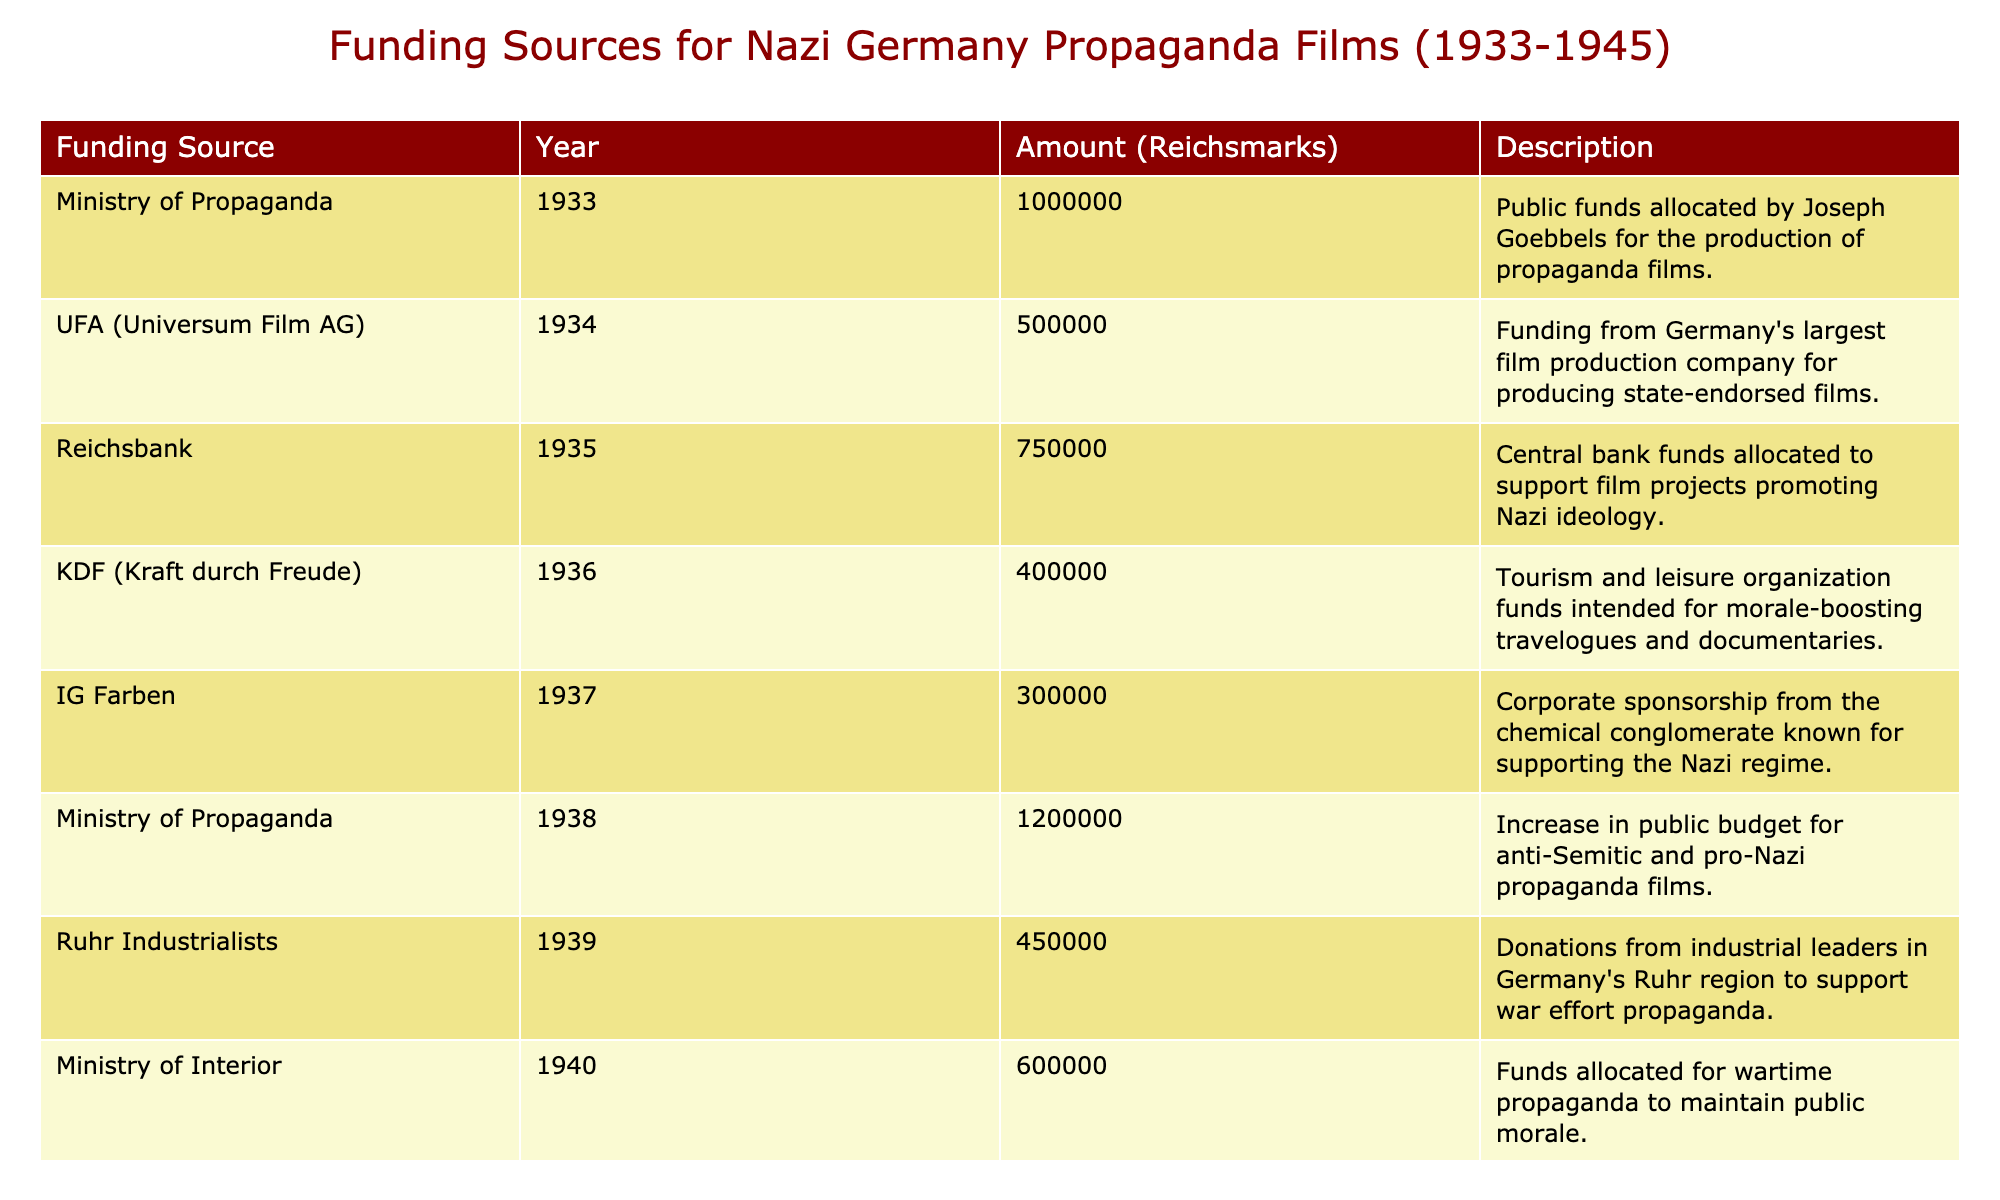What was the total funding from the Ministry of Propaganda across all years? The Ministry of Propaganda provided funding in the years 1933 (1,000,000), 1938 (1,200,000), 1941 (1,300,000), and 1945 (1,400,000). Summing these amounts gives 1,000,000 + 1,200,000 + 1,300,000 + 1,400,000 = 4,900,000.
Answer: 4,900,000 Which funding source contributed the most amount in 1941? In 1941, the Ministry of Propaganda contributed 1,300,000, which is higher than any other funding source listed for that year.
Answer: Ministry of Propaganda Was there an increase in funding from the Ministry of Propaganda from 1933 to 1945? The funding from the Ministry of Propaganda was 1,000,000 in 1933 and increased to 1,400,000 in 1945. Since 1,400,000 is greater than 1,000,000, it confirms an increase.
Answer: Yes What is the average amount funded by corporate sponsors (IG Farben, Deutsche Bank, Siemens) in the table? The amounts from corporate sponsors are IG Farben (300,000), Deutsche Bank (500,000), and Siemens (350,000). The total is 300,000 + 500,000 + 350,000 = 1,150,000. The average is 1,150,000 / 3 = 383,333.33.
Answer: 383,333.33 Did KDF provide more funding than UFA in 1934? KDF did not provide funding in 1934, while UFA provided 500,000. Since 0 is less than 500,000, KDF's funding is less than UFA's.
Answer: No Which year had the highest funding source overall? Examining the table, the highest funding is noted in 1945 from the Ministry of Propaganda, which contributed 1,400,000, the highest amount in the table overall.
Answer: 1945 What was the cumulative funding from all sources in 1936 through 1940? The amounts for those years are 400,000 (1936 KDF) + 750,000 (1935 Reichsbank) + 450,000 (1939 Ruhr Industrialists) + 600,000 (1940 Ministry of Interior) = 400,000 + 750,000 + 450,000 + 600,000 = 2,200,000.
Answer: 2,200,000 Was the funding from UFA consistent across the years it appeared? UFA had a contribution of 500,000 in 1934, but there is no further data in the table to suggest ongoing funding over the years. Therefore, it cannot be termed consistent as it appeared only once.
Answer: No Which funding source provided the least amount in 1937? The only funding source in 1937 is IG Farben, which provided 300,000. As there are no other entries for that year, by default, it is the least amount.
Answer: IG Farben 